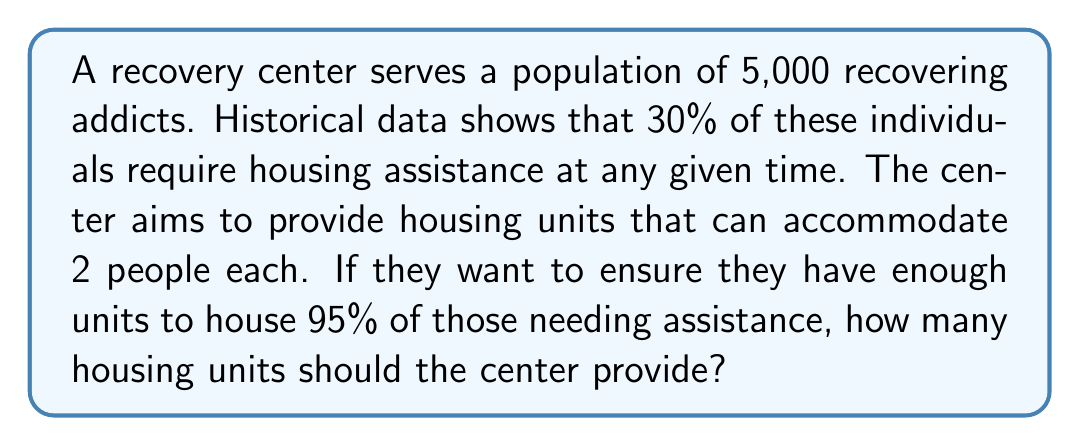Help me with this question. Let's break this down step-by-step:

1) First, calculate the number of individuals needing housing assistance:
   $$ 5,000 \times 0.30 = 1,500 \text{ individuals} $$

2) To house 95% of these individuals:
   $$ 1,500 \times 0.95 = 1,425 \text{ individuals to be housed} $$

3) Each unit houses 2 people, so divide the number of individuals by 2:
   $$ \frac{1,425}{2} = 712.5 \text{ units} $$

4) Since we can't have half a unit, we round up to the nearest whole number:
   $$ \lceil 712.5 \rceil = 713 \text{ units} $$

Therefore, the recovery center should provide 713 housing units to meet the stated requirements.
Answer: 713 units 